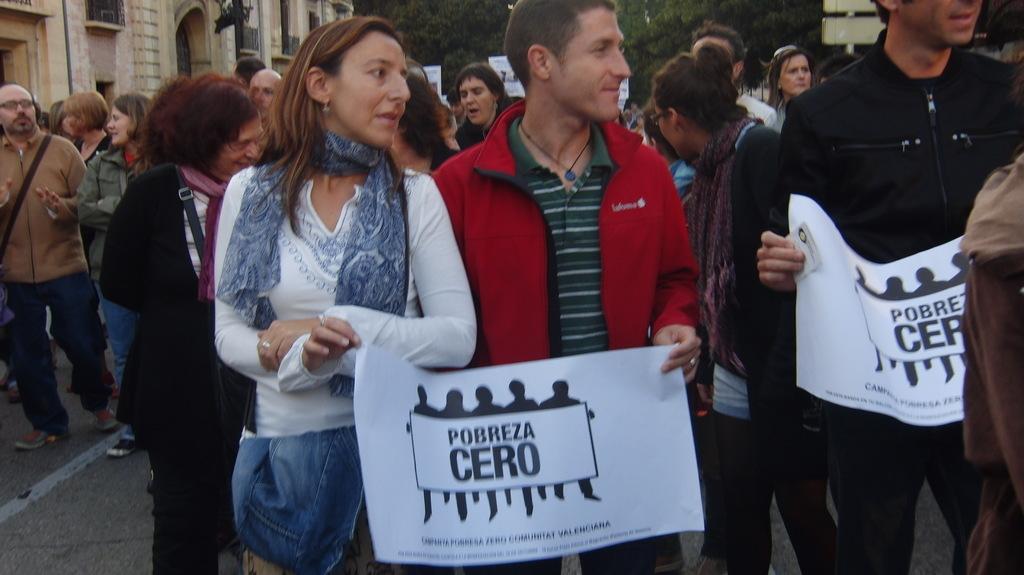How would you summarize this image in a sentence or two? In this image I can see few persons. Some of them are holding few posters. There is some text on it. 